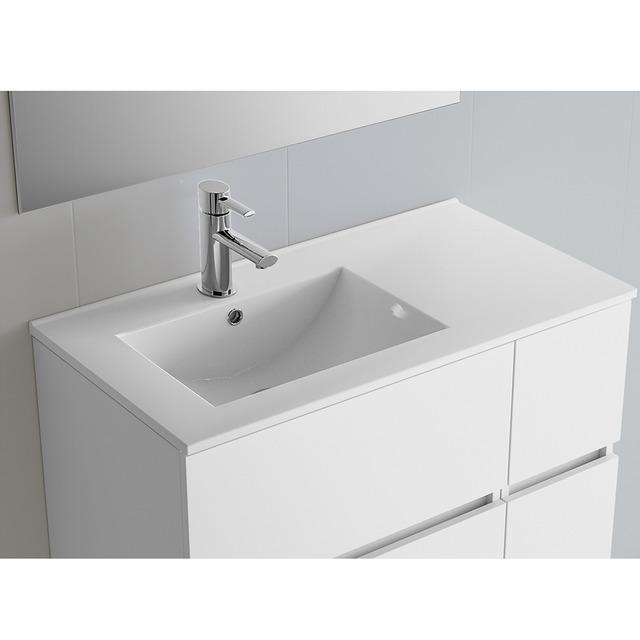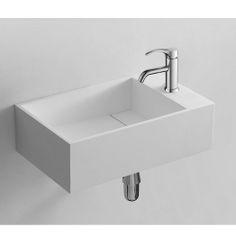The first image is the image on the left, the second image is the image on the right. For the images shown, is this caption "A vanity includes one rectangular white sink and a brown cabinet with multiple drawers." true? Answer yes or no. No. The first image is the image on the left, the second image is the image on the right. For the images displayed, is the sentence "In at least one image, a mirror is clearly visible above a bathroom sink" factually correct? Answer yes or no. No. 